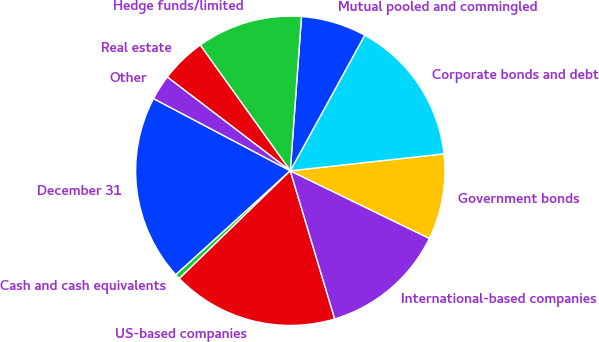Convert chart to OTSL. <chart><loc_0><loc_0><loc_500><loc_500><pie_chart><fcel>December 31<fcel>Cash and cash equivalents<fcel>US-based companies<fcel>International-based companies<fcel>Government bonds<fcel>Corporate bonds and debt<fcel>Mutual pooled and commingled<fcel>Hedge funds/limited<fcel>Real estate<fcel>Other<nl><fcel>19.47%<fcel>0.53%<fcel>17.37%<fcel>13.16%<fcel>8.95%<fcel>15.26%<fcel>6.84%<fcel>11.05%<fcel>4.74%<fcel>2.63%<nl></chart> 